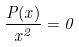Convert formula to latex. <formula><loc_0><loc_0><loc_500><loc_500>\frac { P ( x ) } { x ^ { 2 } } = 0</formula> 